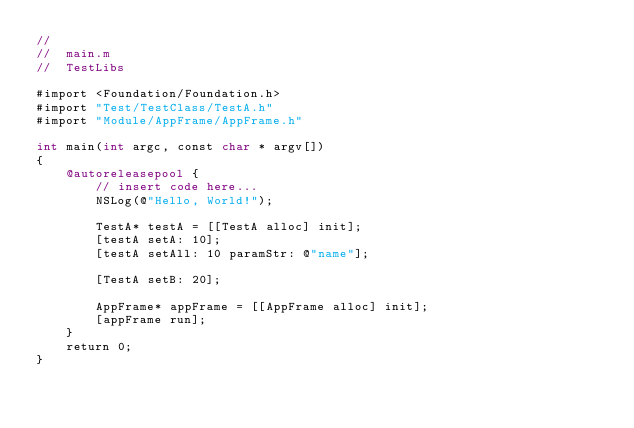Convert code to text. <code><loc_0><loc_0><loc_500><loc_500><_ObjectiveC_>//
//  main.m
//  TestLibs

#import <Foundation/Foundation.h>
#import "Test/TestClass/TestA.h"
#import "Module/AppFrame/AppFrame.h"

int main(int argc, const char * argv[])
{
    @autoreleasepool {
        // insert code here...
        NSLog(@"Hello, World!");
        
        TestA* testA = [[TestA alloc] init];
        [testA setA: 10];
        [testA setAll: 10 paramStr: @"name"];
        
        [TestA setB: 20];

        AppFrame* appFrame = [[AppFrame alloc] init];
        [appFrame run];
    }
    return 0;
}
</code> 